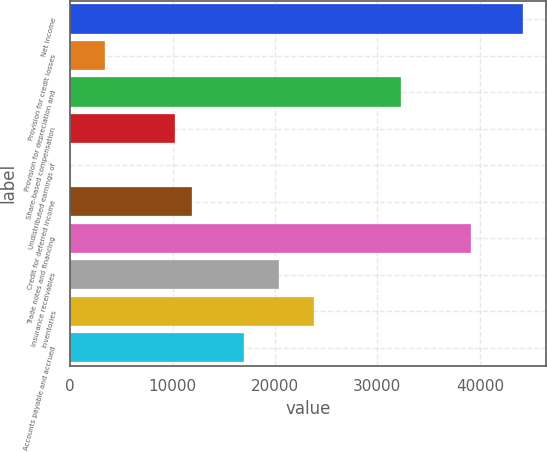Convert chart. <chart><loc_0><loc_0><loc_500><loc_500><bar_chart><fcel>Net income<fcel>Provision for credit losses<fcel>Provision for depreciation and<fcel>Share-based compensation<fcel>Undistributed earnings of<fcel>Credit for deferred income<fcel>Trade notes and financing<fcel>Insurance receivables<fcel>Inventories<fcel>Accounts payable and accrued<nl><fcel>44215.9<fcel>3409.62<fcel>32314<fcel>10210.7<fcel>9.1<fcel>11910.9<fcel>39115.1<fcel>20412.2<fcel>23812.7<fcel>17011.7<nl></chart> 